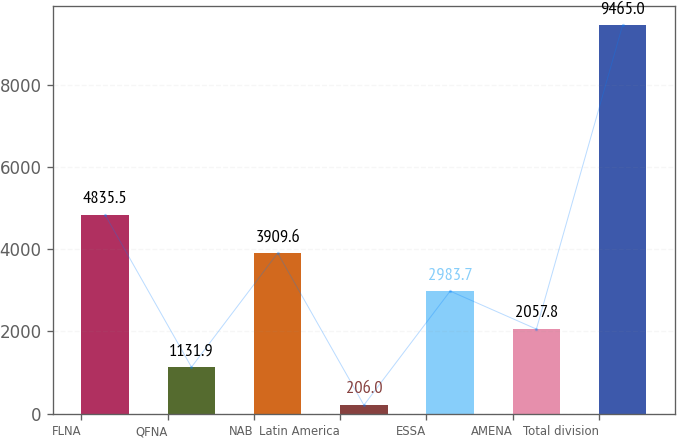Convert chart. <chart><loc_0><loc_0><loc_500><loc_500><bar_chart><fcel>FLNA<fcel>QFNA<fcel>NAB<fcel>Latin America<fcel>ESSA<fcel>AMENA<fcel>Total division<nl><fcel>4835.5<fcel>1131.9<fcel>3909.6<fcel>206<fcel>2983.7<fcel>2057.8<fcel>9465<nl></chart> 